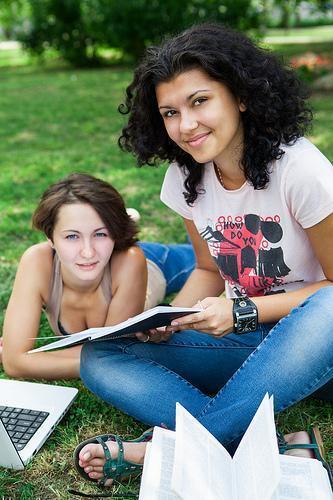How many laptops?
Give a very brief answer. 1. How many t-shirts?
Give a very brief answer. 1. 